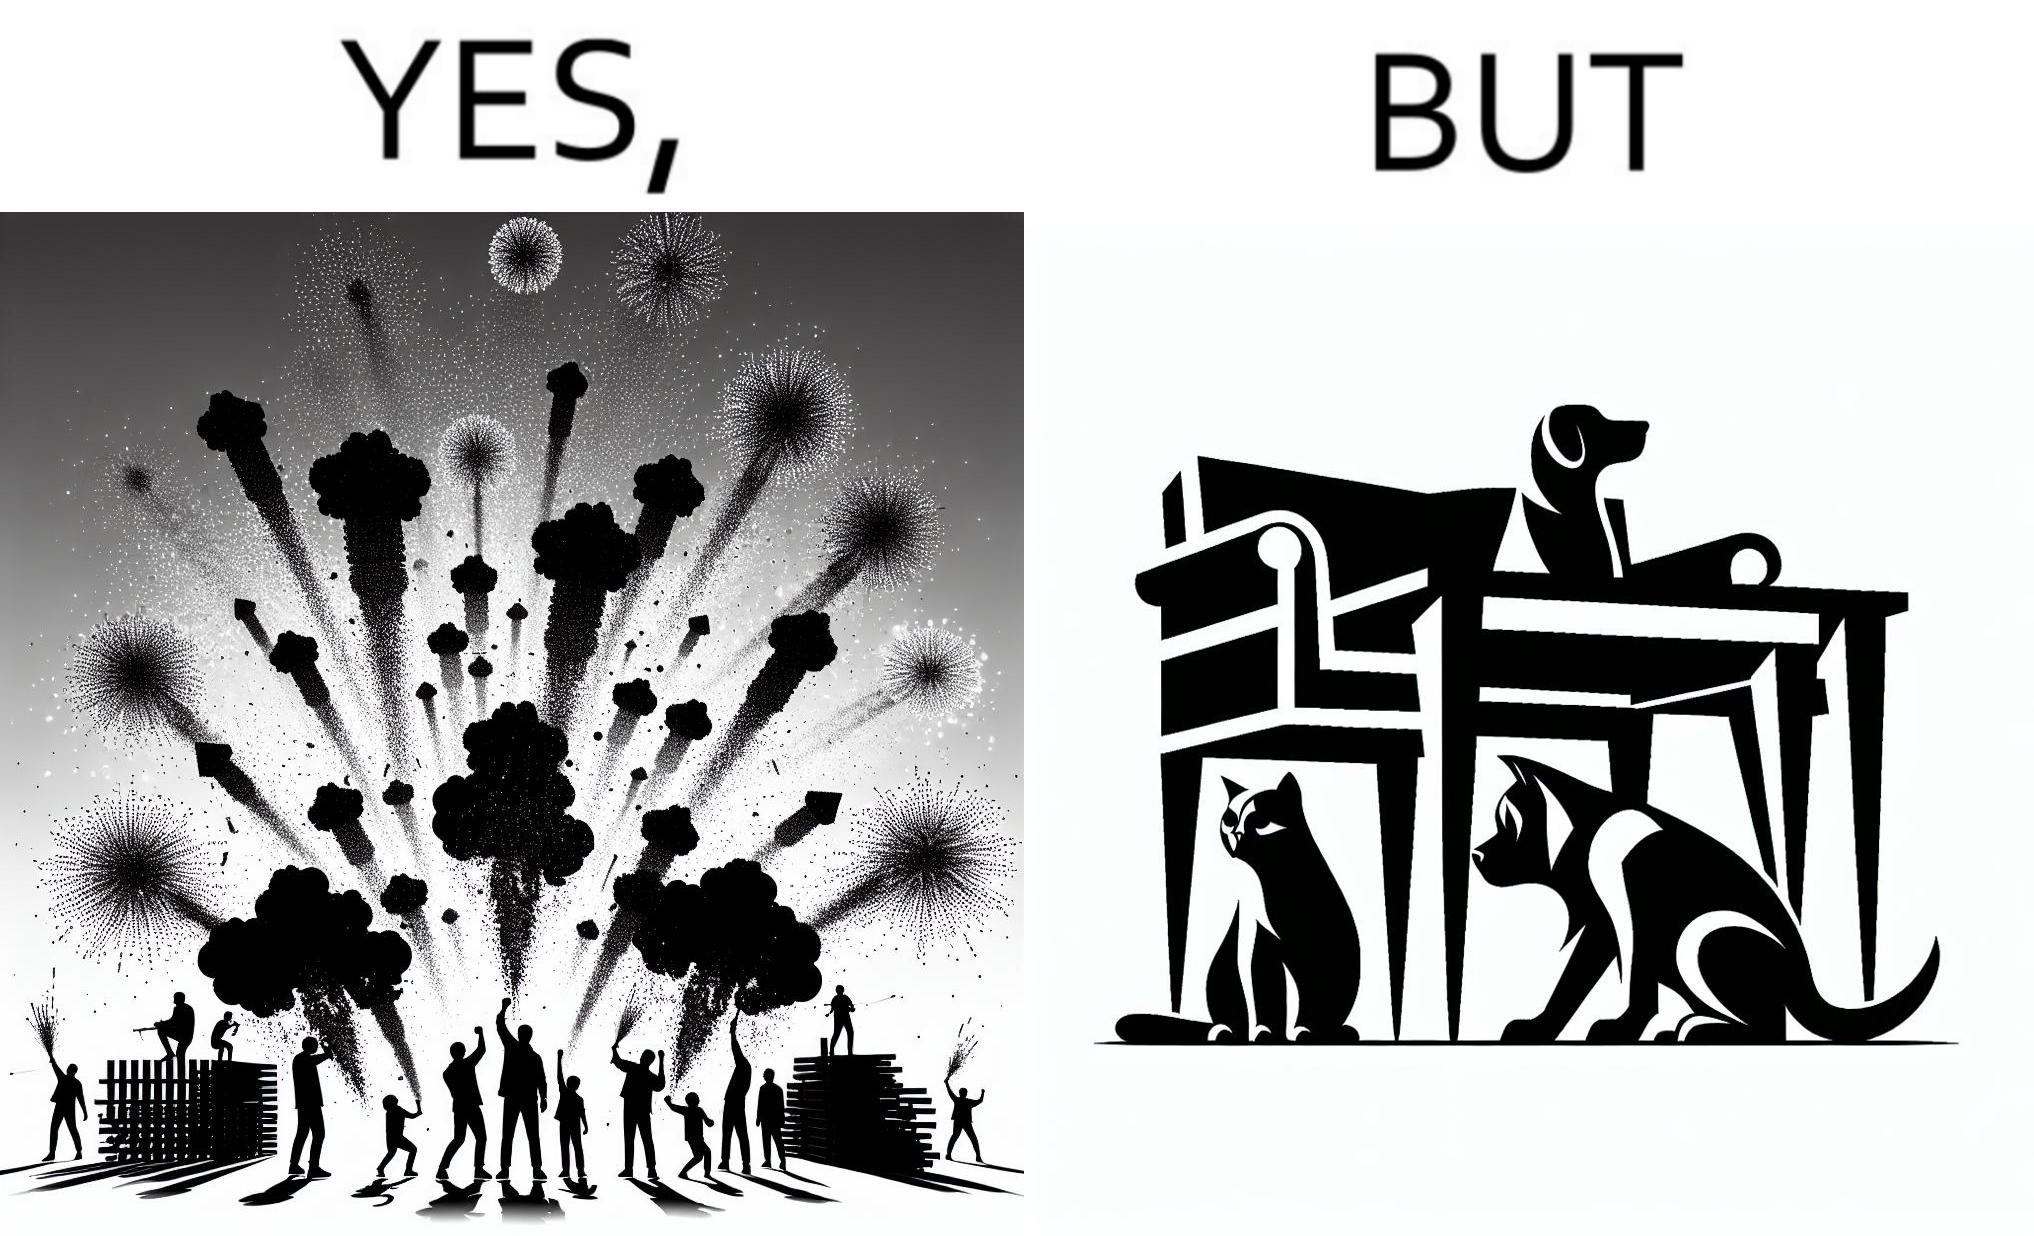Does this image contain satire or humor? Yes, this image is satirical. 